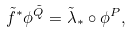<formula> <loc_0><loc_0><loc_500><loc_500>\tilde { f } ^ { * } \phi ^ { \tilde { Q } } = \tilde { \lambda } _ { * } \circ \phi ^ { P } ,</formula> 